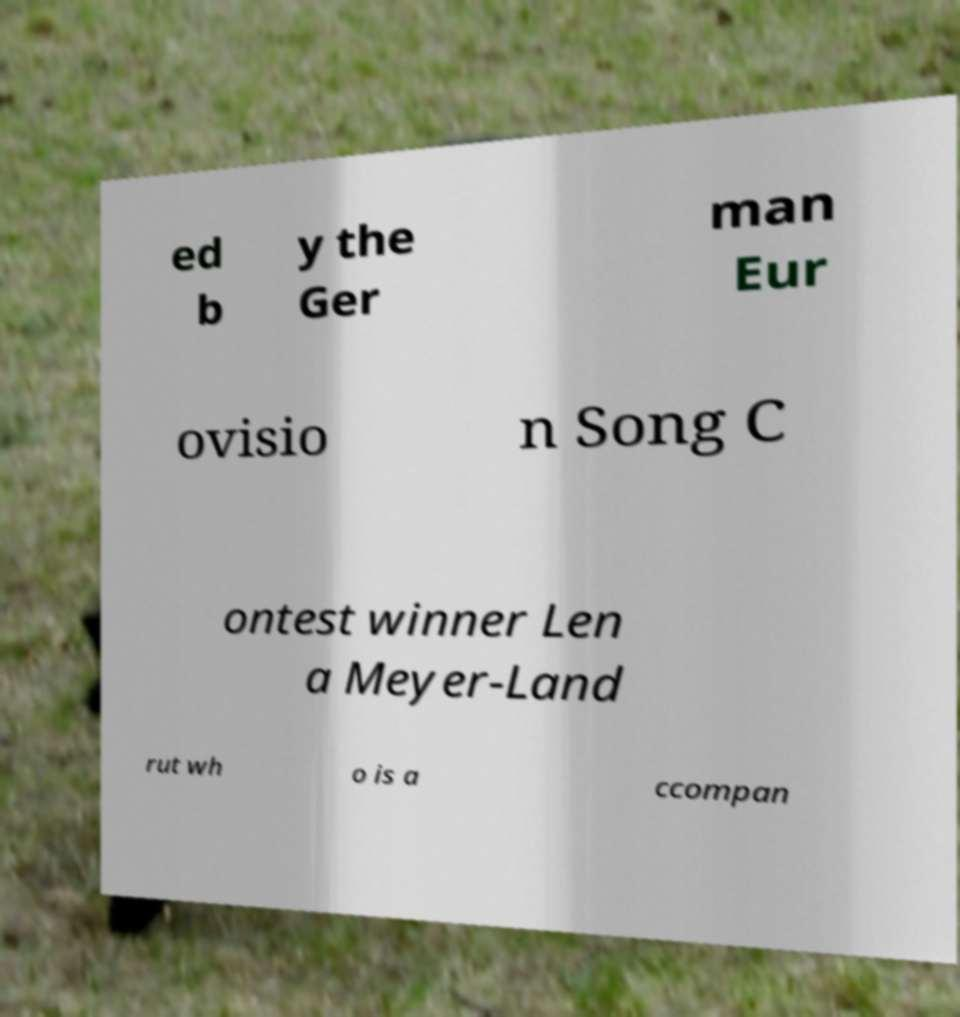Could you assist in decoding the text presented in this image and type it out clearly? ed b y the Ger man Eur ovisio n Song C ontest winner Len a Meyer-Land rut wh o is a ccompan 